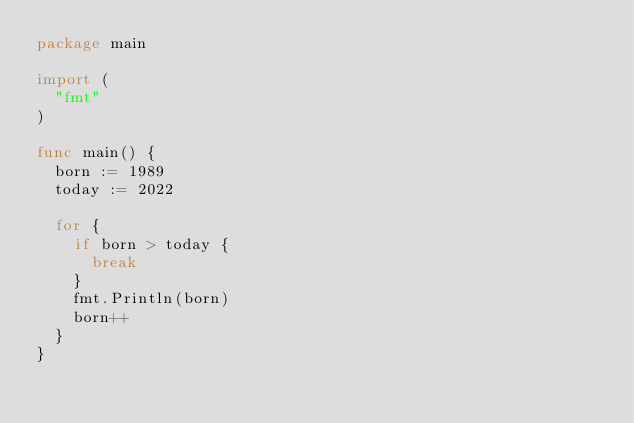Convert code to text. <code><loc_0><loc_0><loc_500><loc_500><_Go_>package main

import (
	"fmt"
)

func main() {
	born := 1989
	today := 2022

	for {
		if born > today {
			break
		}
		fmt.Println(born)
		born++
	}
}
</code> 